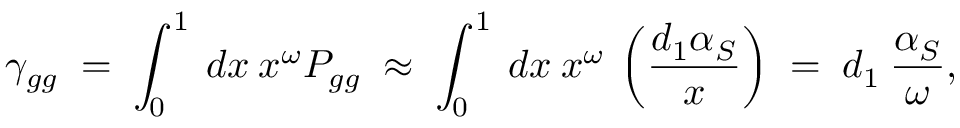<formula> <loc_0><loc_0><loc_500><loc_500>\gamma _ { g g } \, = \, \int _ { 0 } ^ { 1 } \, d x \, x ^ { \omega } P _ { g g } \, \approx \, \int _ { 0 } ^ { 1 } \, d x \, x ^ { \omega } \, \left ( \frac { d _ { 1 } \alpha _ { S } } { x } \right ) \, = \, d _ { 1 } \, \frac { \alpha _ { S } } { \omega } ,</formula> 